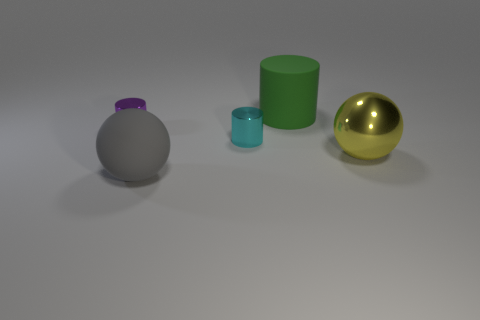How many objects are large matte objects or things behind the big shiny thing?
Give a very brief answer. 4. There is a matte object that is in front of the purple object; does it have the same size as the object on the left side of the gray rubber sphere?
Offer a terse response. No. There is a yellow metallic object; is its size the same as the thing that is in front of the big shiny ball?
Your answer should be very brief. Yes. There is a matte object to the right of the ball to the left of the yellow shiny thing; how big is it?
Provide a succinct answer. Large. What is the color of the other big thing that is the same shape as the cyan thing?
Provide a short and direct response. Green. Does the yellow object have the same size as the rubber ball?
Your answer should be very brief. Yes. Is the number of small cyan objects left of the cyan metal thing the same as the number of blue metal balls?
Provide a succinct answer. Yes. There is a thing in front of the shiny sphere; are there any yellow objects that are behind it?
Give a very brief answer. Yes. How big is the metallic object that is to the right of the large thing that is behind the small metallic object that is to the left of the gray matte object?
Provide a short and direct response. Large. What material is the sphere on the right side of the large ball on the left side of the rubber cylinder?
Ensure brevity in your answer.  Metal. 